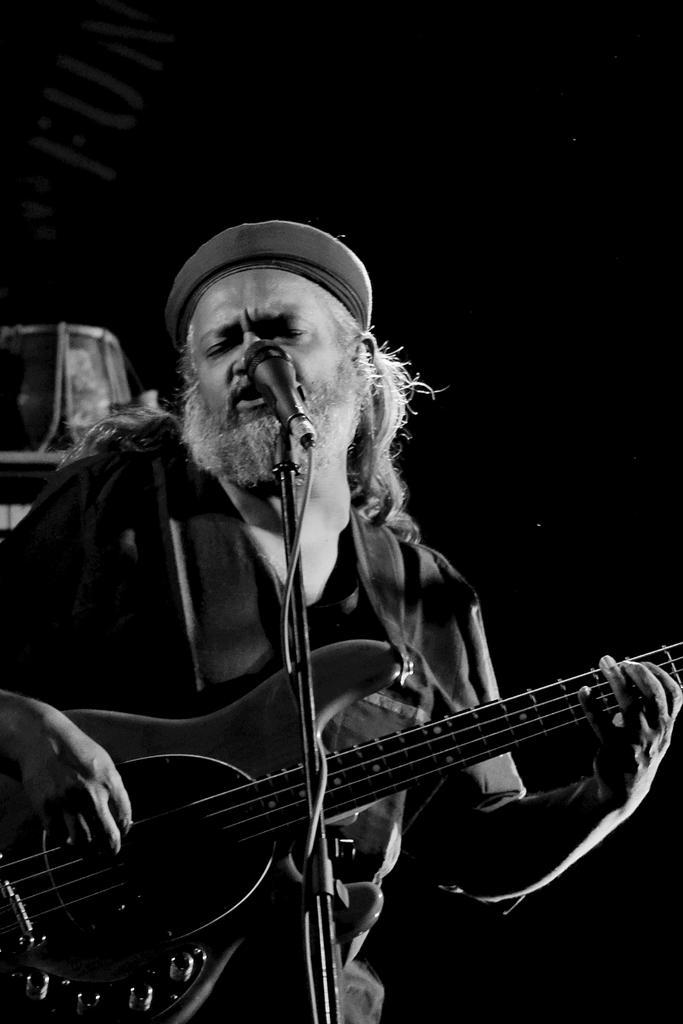Please provide a concise description of this image. In the middle of the image a man standing and playing guitar and singing. In front of him there is a microphone. Behind him there is a drum. 